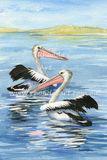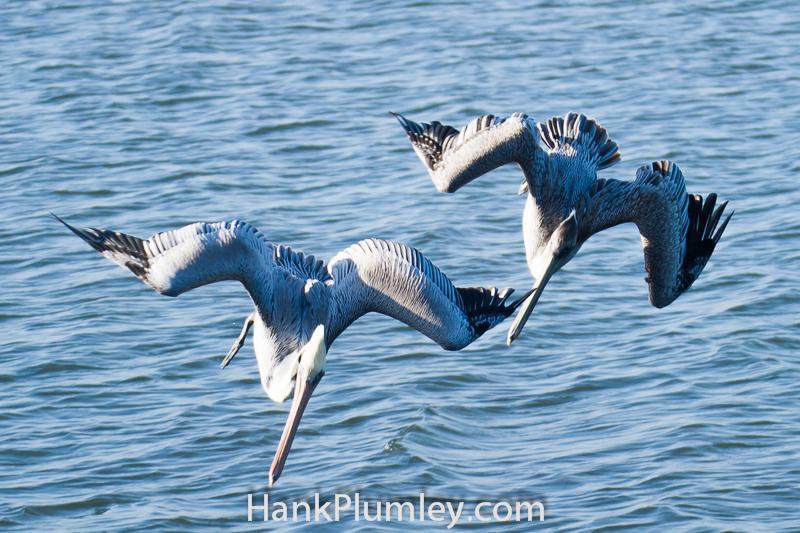The first image is the image on the left, the second image is the image on the right. Evaluate the accuracy of this statement regarding the images: "At least one pelican is diving for food with its head in the water.". Is it true? Answer yes or no. No. The first image is the image on the left, the second image is the image on the right. Given the left and right images, does the statement "One image shows two pelicans in flight above the water, and the other image shows two pelicans that have plunged into the water." hold true? Answer yes or no. No. 